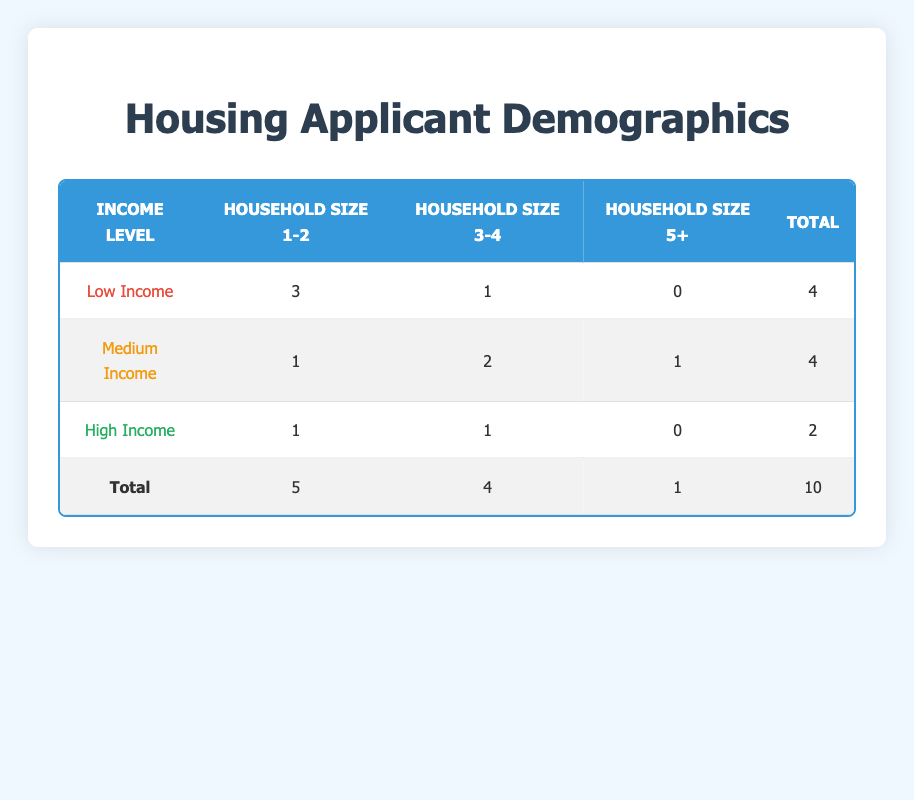What is the total number of applicants with a low income level? There are 4 applicants listed under the low income level row of the table. The total is directly provided in the "Total" column for that income level.
Answer: 4 How many applicants belong to a household size of 3 or 4 and have a medium income level? The medium income row shows that there are 2 applicants in the household size of 3 and 1 applicant in the household size of 4. Adding these together gives 2 + 1 = 3.
Answer: 3 Is there any applicant with a high income level who lives in a household with 5 or more members? Upon checking the row for high income, the data shows that there are 0 applicants in the household size column for 5+. Therefore, the answer is no.
Answer: No What is the total number of applicants across all income levels for households with a size of 2? Looking at the table, the number of applicants in the "Household Size 1-2" column sums up to 5 (3 low income + 1 medium income + 1 high income).
Answer: 5 Which income level has the highest number of applicants in household size 3 or larger? By comparing the totals for each income level in the "Household Size 3-4" and "Household Size 5+" columns, we find that the low income has 1 in size 3-4, the medium has 2 in size 3-4 and 1 in size 5+ (total of 3), and the high has 1 in size 3-4. Therefore, medium income has the highest with 3.
Answer: Medium Income How many total applicants are there for all income levels who have a household size of 5 or more? The relevant information is in the last column for each income level which shows that there is 1 applicant in total with a household size of 5 or more (only from medium income).
Answer: 1 